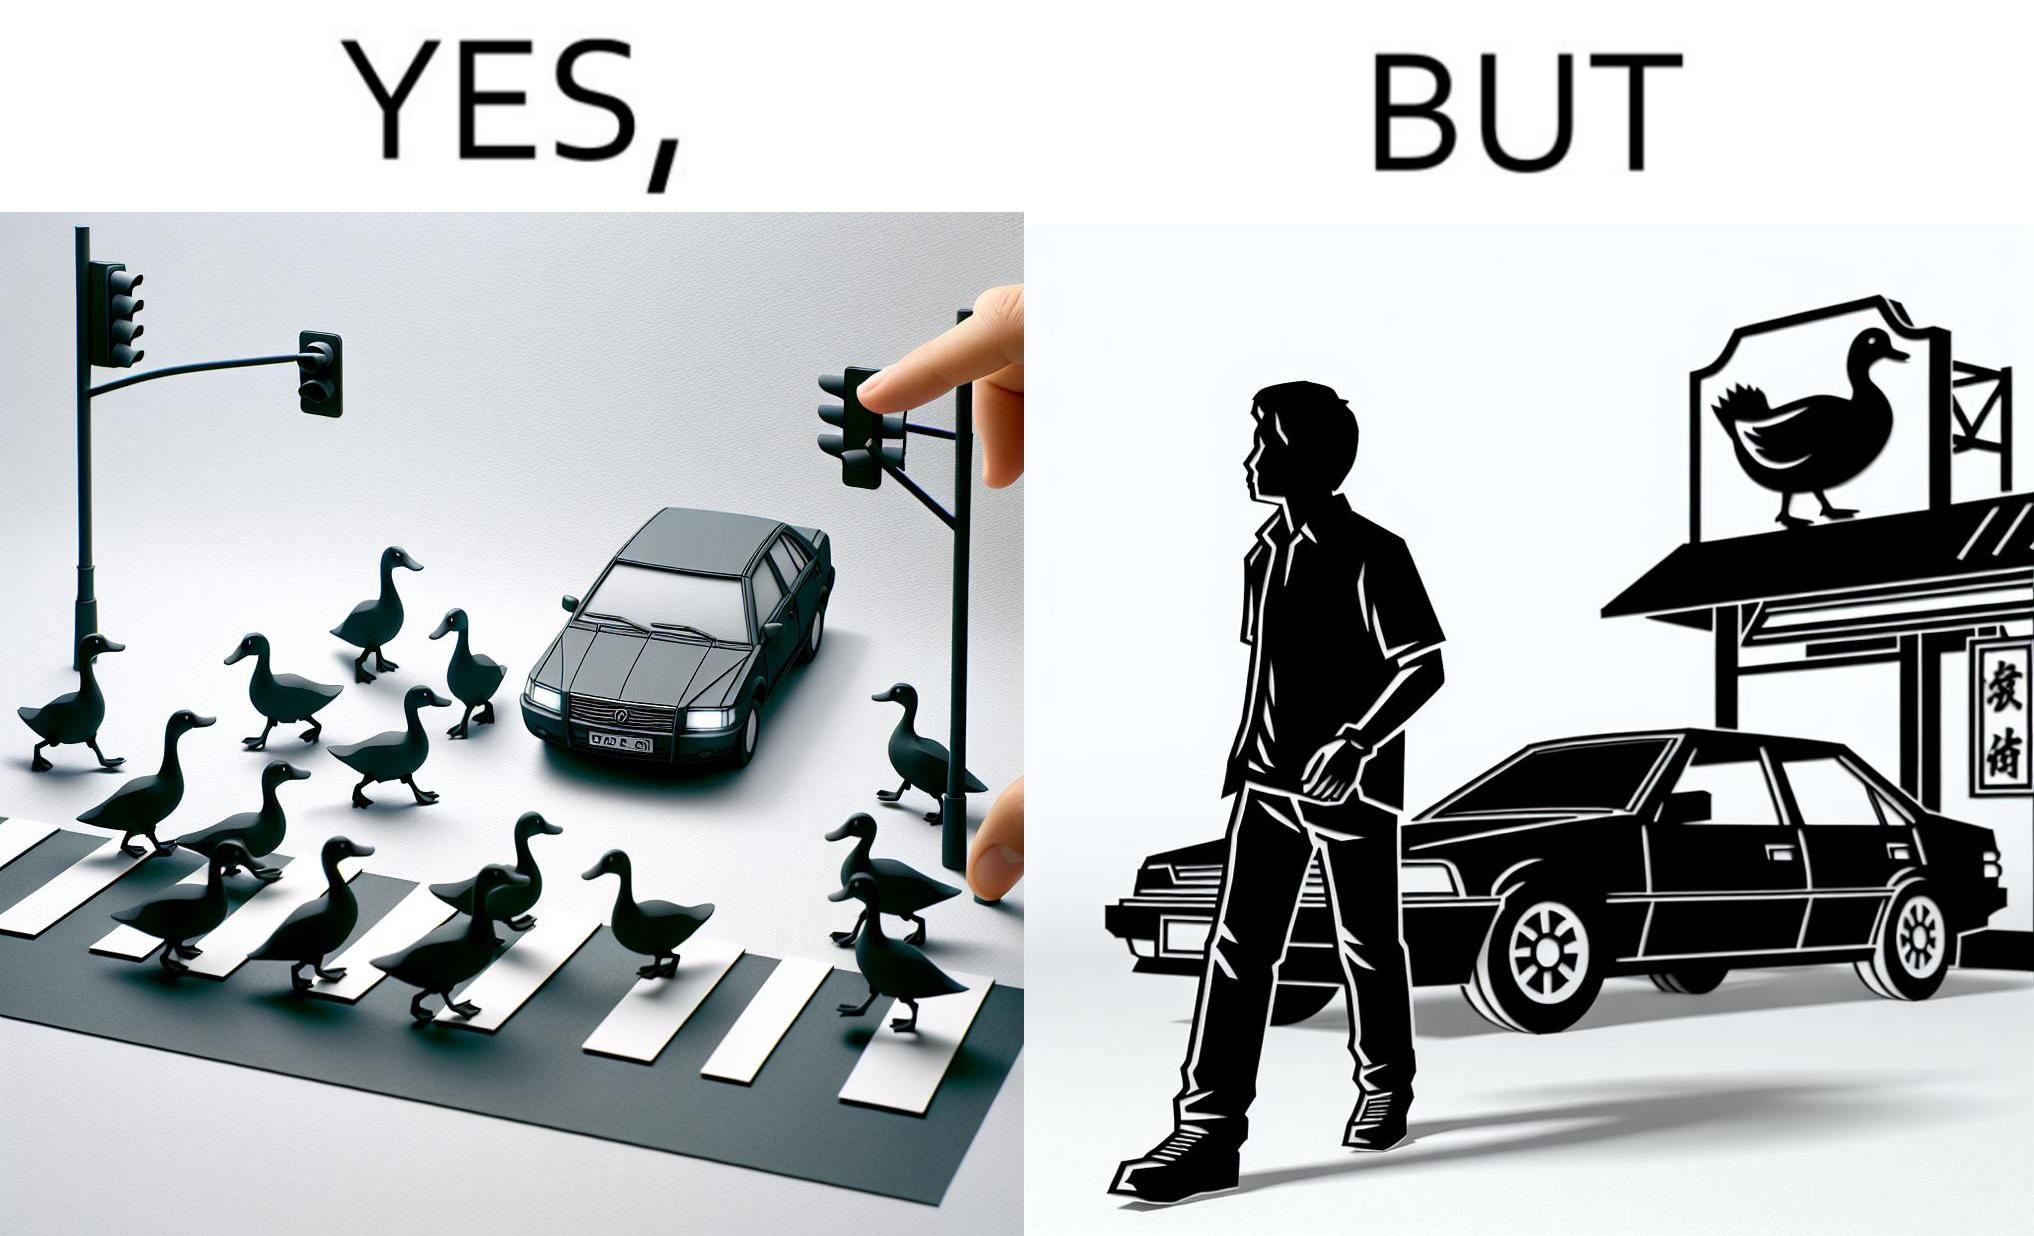Is this a satirical image? Yes, this image is satirical. 